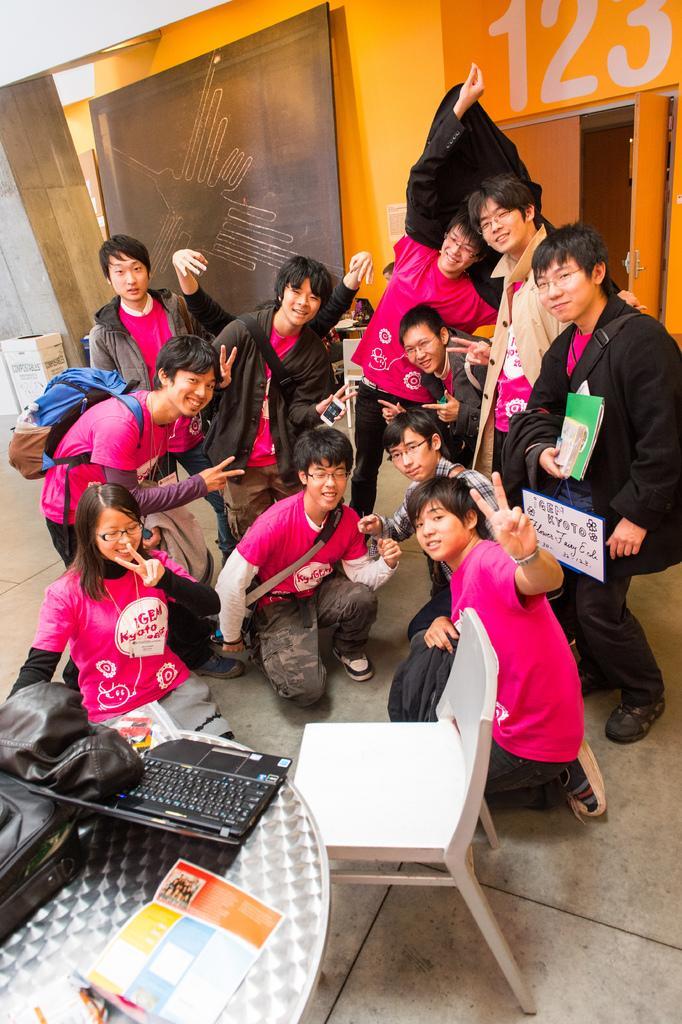Describe this image in one or two sentences. In this image I can see people and also I can see smile on their faces. I can see all of them are wearing same color of dresses. Here I can see a chair and a table. On this table I can see a bag, a jacket, a laptop and a paper. 